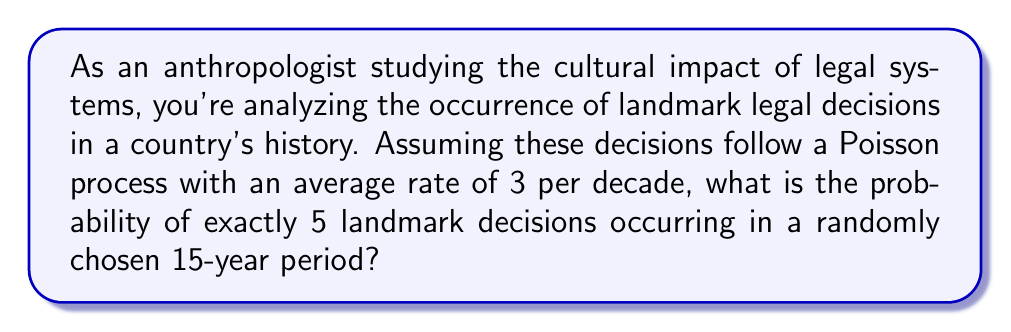Solve this math problem. To solve this problem, we'll use the Poisson distribution formula and follow these steps:

1. Identify the given information:
   - The rate (λ) is 3 landmark decisions per decade
   - We're looking at a 15-year period
   - We want the probability of exactly 5 landmark decisions

2. Adjust the rate for the 15-year period:
   λ₁₅ = 3 * (15/10) = 4.5 landmark decisions per 15 years

3. Use the Poisson probability mass function:
   $P(X = k) = \frac{e^{-λ} λ^k}{k!}$
   Where:
   - e is Euler's number (≈ 2.71828)
   - λ is the adjusted rate (4.5)
   - k is the number of events we're interested in (5)

4. Plug in the values:
   $P(X = 5) = \frac{e^{-4.5} 4.5^5}{5!}$

5. Calculate:
   $P(X = 5) = \frac{2.71828^{-4.5} * 4.5^5}{5 * 4 * 3 * 2 * 1}$
   $= \frac{0.0111 * 1845.28125}{120}$
   $= \frac{20.48262}{120}$
   $≈ 0.1707$

Therefore, the probability of exactly 5 landmark legal decisions occurring in a randomly chosen 15-year period is approximately 0.1707 or 17.07%.
Answer: 0.1707 